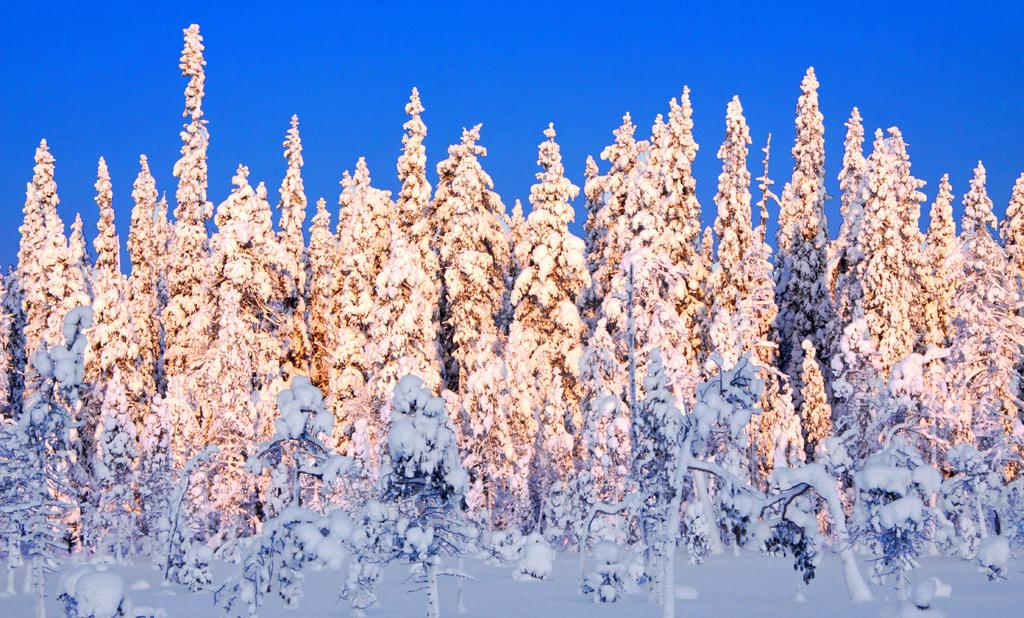What color is the background of the image? The background of the image is blue. What type of vegetation can be seen in the image? There are plants in the image. What weather condition is depicted in the image? There is snow in the image. How many tents are set up in the image? There are no tents present in the image. What type of fruit can be seen falling from the plants in the image? There are no fruits visible in the image, and the plants do not appear to be fruit-bearing plants. 